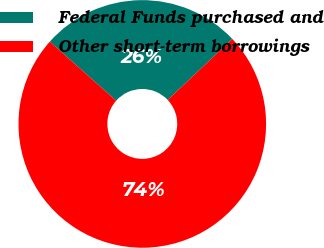<chart> <loc_0><loc_0><loc_500><loc_500><pie_chart><fcel>Federal Funds purchased and<fcel>Other short-term borrowings<nl><fcel>26.39%<fcel>73.61%<nl></chart> 